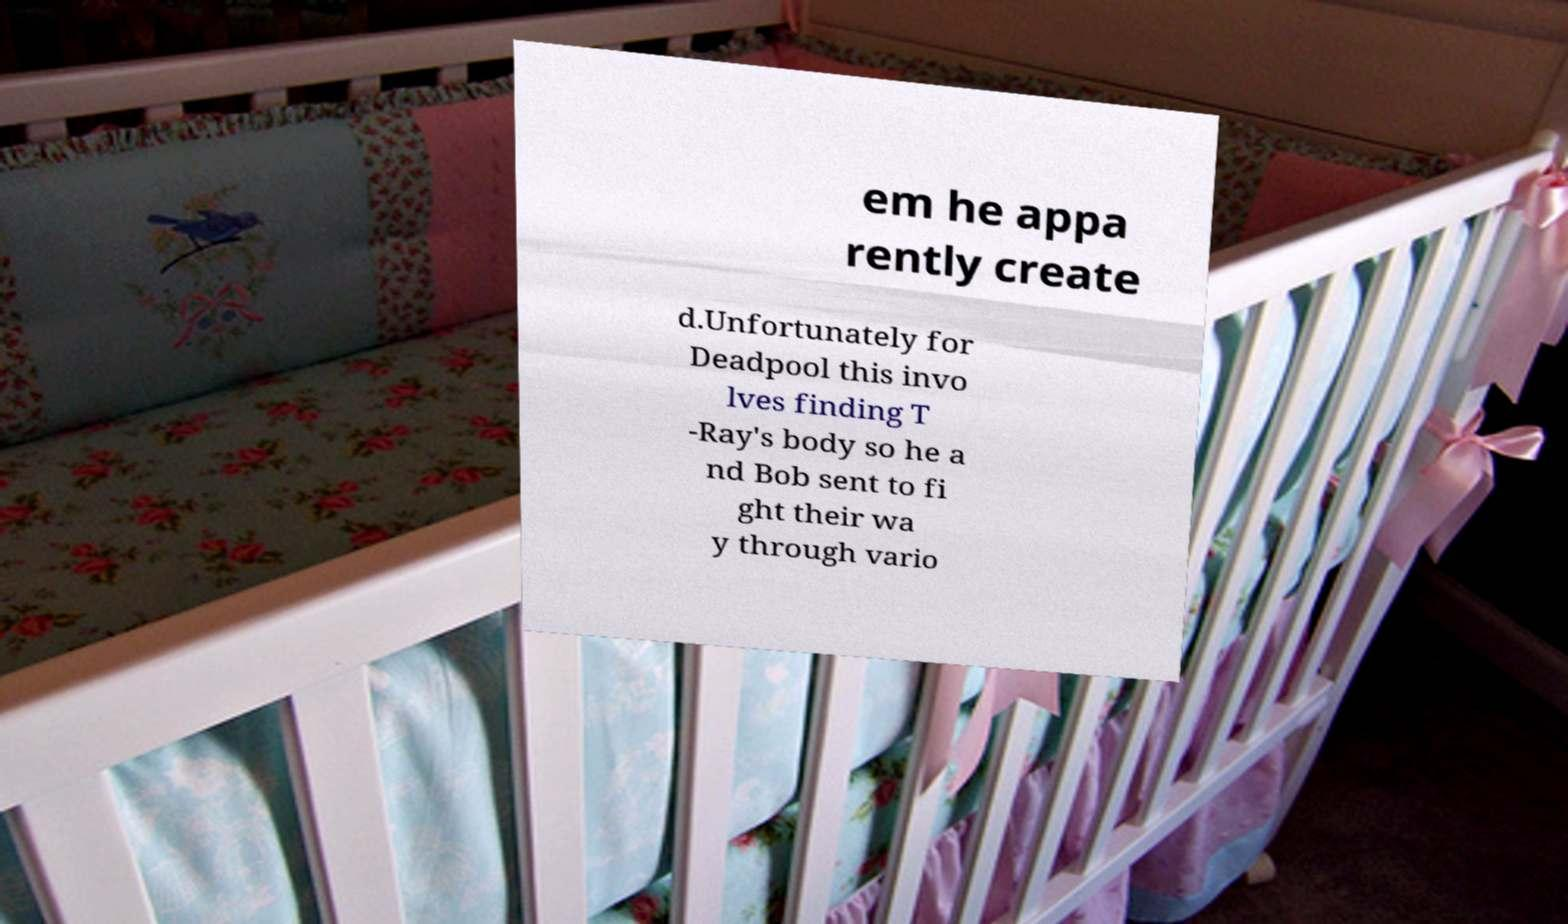Please read and relay the text visible in this image. What does it say? em he appa rently create d.Unfortunately for Deadpool this invo lves finding T -Ray's body so he a nd Bob sent to fi ght their wa y through vario 